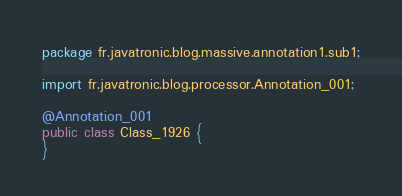Convert code to text. <code><loc_0><loc_0><loc_500><loc_500><_Java_>package fr.javatronic.blog.massive.annotation1.sub1;

import fr.javatronic.blog.processor.Annotation_001;

@Annotation_001
public class Class_1926 {
}
</code> 